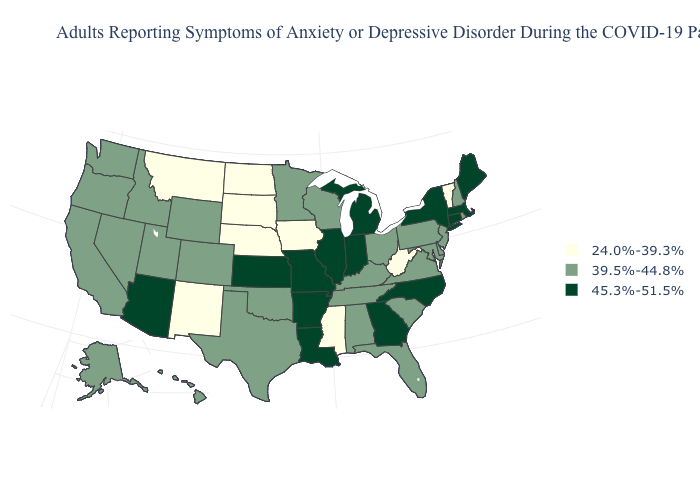Name the states that have a value in the range 24.0%-39.3%?
Give a very brief answer. Iowa, Mississippi, Montana, Nebraska, New Mexico, North Dakota, South Dakota, Vermont, West Virginia. What is the value of Texas?
Keep it brief. 39.5%-44.8%. Name the states that have a value in the range 45.3%-51.5%?
Write a very short answer. Arizona, Arkansas, Connecticut, Georgia, Illinois, Indiana, Kansas, Louisiana, Maine, Massachusetts, Michigan, Missouri, New York, North Carolina. Does Missouri have the highest value in the MidWest?
Quick response, please. Yes. What is the value of Vermont?
Concise answer only. 24.0%-39.3%. Which states hav the highest value in the South?
Quick response, please. Arkansas, Georgia, Louisiana, North Carolina. What is the value of Iowa?
Be succinct. 24.0%-39.3%. Name the states that have a value in the range 45.3%-51.5%?
Give a very brief answer. Arizona, Arkansas, Connecticut, Georgia, Illinois, Indiana, Kansas, Louisiana, Maine, Massachusetts, Michigan, Missouri, New York, North Carolina. Is the legend a continuous bar?
Keep it brief. No. What is the lowest value in the USA?
Answer briefly. 24.0%-39.3%. What is the lowest value in the USA?
Write a very short answer. 24.0%-39.3%. What is the lowest value in states that border Nebraska?
Concise answer only. 24.0%-39.3%. What is the highest value in states that border New York?
Write a very short answer. 45.3%-51.5%. What is the value of Nevada?
Short answer required. 39.5%-44.8%. What is the lowest value in the USA?
Short answer required. 24.0%-39.3%. 